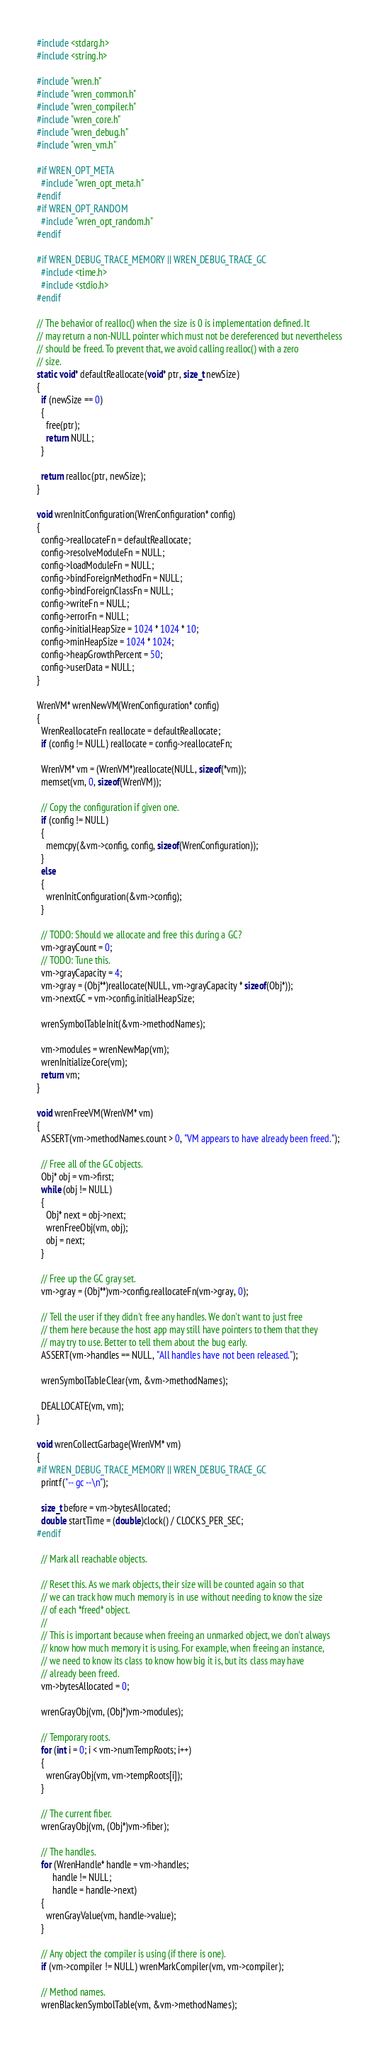Convert code to text. <code><loc_0><loc_0><loc_500><loc_500><_C_>#include <stdarg.h>
#include <string.h>

#include "wren.h"
#include "wren_common.h"
#include "wren_compiler.h"
#include "wren_core.h"
#include "wren_debug.h"
#include "wren_vm.h"

#if WREN_OPT_META
  #include "wren_opt_meta.h"
#endif
#if WREN_OPT_RANDOM
  #include "wren_opt_random.h"
#endif

#if WREN_DEBUG_TRACE_MEMORY || WREN_DEBUG_TRACE_GC
  #include <time.h>
  #include <stdio.h>
#endif

// The behavior of realloc() when the size is 0 is implementation defined. It
// may return a non-NULL pointer which must not be dereferenced but nevertheless
// should be freed. To prevent that, we avoid calling realloc() with a zero
// size.
static void* defaultReallocate(void* ptr, size_t newSize)
{
  if (newSize == 0)
  {
    free(ptr);
    return NULL;
  }

  return realloc(ptr, newSize);
}

void wrenInitConfiguration(WrenConfiguration* config)
{
  config->reallocateFn = defaultReallocate;
  config->resolveModuleFn = NULL;
  config->loadModuleFn = NULL;
  config->bindForeignMethodFn = NULL;
  config->bindForeignClassFn = NULL;
  config->writeFn = NULL;
  config->errorFn = NULL;
  config->initialHeapSize = 1024 * 1024 * 10;
  config->minHeapSize = 1024 * 1024;
  config->heapGrowthPercent = 50;
  config->userData = NULL;
}

WrenVM* wrenNewVM(WrenConfiguration* config)
{
  WrenReallocateFn reallocate = defaultReallocate;
  if (config != NULL) reallocate = config->reallocateFn;
  
  WrenVM* vm = (WrenVM*)reallocate(NULL, sizeof(*vm));
  memset(vm, 0, sizeof(WrenVM));

  // Copy the configuration if given one.
  if (config != NULL)
  {
    memcpy(&vm->config, config, sizeof(WrenConfiguration));
  }
  else
  {
    wrenInitConfiguration(&vm->config);
  }

  // TODO: Should we allocate and free this during a GC?
  vm->grayCount = 0;
  // TODO: Tune this.
  vm->grayCapacity = 4;
  vm->gray = (Obj**)reallocate(NULL, vm->grayCapacity * sizeof(Obj*));
  vm->nextGC = vm->config.initialHeapSize;

  wrenSymbolTableInit(&vm->methodNames);

  vm->modules = wrenNewMap(vm);
  wrenInitializeCore(vm);
  return vm;
}

void wrenFreeVM(WrenVM* vm)
{
  ASSERT(vm->methodNames.count > 0, "VM appears to have already been freed.");
  
  // Free all of the GC objects.
  Obj* obj = vm->first;
  while (obj != NULL)
  {
    Obj* next = obj->next;
    wrenFreeObj(vm, obj);
    obj = next;
  }

  // Free up the GC gray set.
  vm->gray = (Obj**)vm->config.reallocateFn(vm->gray, 0);

  // Tell the user if they didn't free any handles. We don't want to just free
  // them here because the host app may still have pointers to them that they
  // may try to use. Better to tell them about the bug early.
  ASSERT(vm->handles == NULL, "All handles have not been released.");

  wrenSymbolTableClear(vm, &vm->methodNames);

  DEALLOCATE(vm, vm);
}

void wrenCollectGarbage(WrenVM* vm)
{
#if WREN_DEBUG_TRACE_MEMORY || WREN_DEBUG_TRACE_GC
  printf("-- gc --\n");

  size_t before = vm->bytesAllocated;
  double startTime = (double)clock() / CLOCKS_PER_SEC;
#endif

  // Mark all reachable objects.

  // Reset this. As we mark objects, their size will be counted again so that
  // we can track how much memory is in use without needing to know the size
  // of each *freed* object.
  //
  // This is important because when freeing an unmarked object, we don't always
  // know how much memory it is using. For example, when freeing an instance,
  // we need to know its class to know how big it is, but its class may have
  // already been freed.
  vm->bytesAllocated = 0;

  wrenGrayObj(vm, (Obj*)vm->modules);

  // Temporary roots.
  for (int i = 0; i < vm->numTempRoots; i++)
  {
    wrenGrayObj(vm, vm->tempRoots[i]);
  }

  // The current fiber.
  wrenGrayObj(vm, (Obj*)vm->fiber);

  // The handles.
  for (WrenHandle* handle = vm->handles;
       handle != NULL;
       handle = handle->next)
  {
    wrenGrayValue(vm, handle->value);
  }

  // Any object the compiler is using (if there is one).
  if (vm->compiler != NULL) wrenMarkCompiler(vm, vm->compiler);

  // Method names.
  wrenBlackenSymbolTable(vm, &vm->methodNames);
</code> 